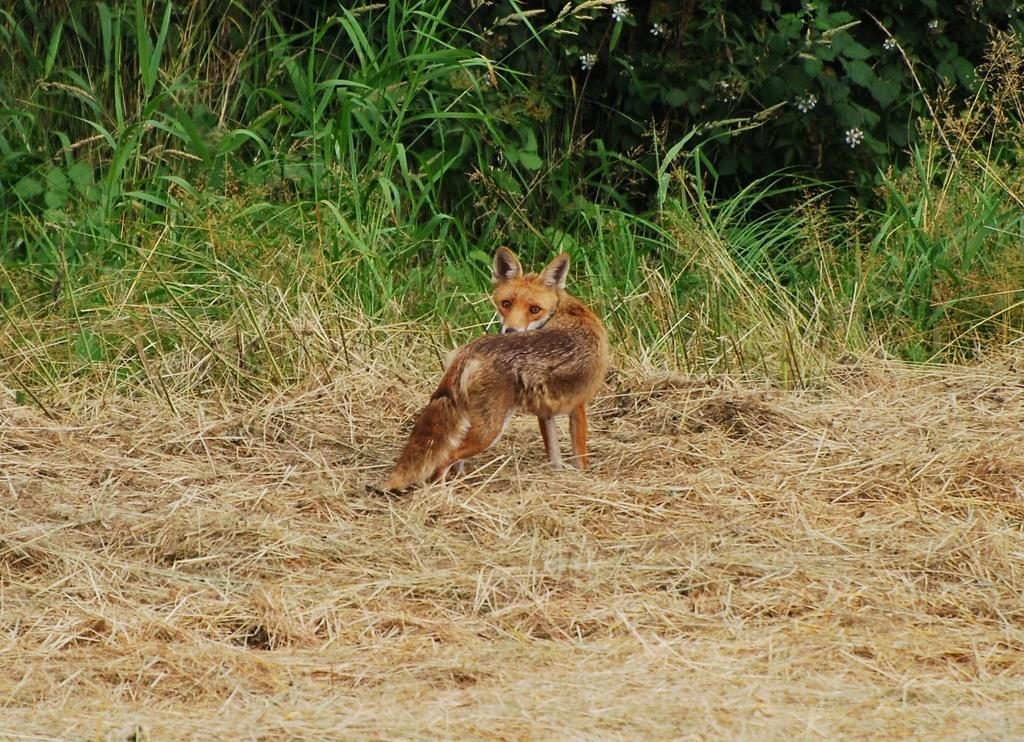What type of animal can be seen in the image? There is an animal in the image, but its specific type cannot be determined from the provided facts. What is the animal standing on? The animal is on dried grass. What can be seen in the background of the image? There are plants visible in the background of the image. What organization does the animal's grandfather belong to in the image? There is no mention of an organization or a grandfather in the image, so this question cannot be answered. 